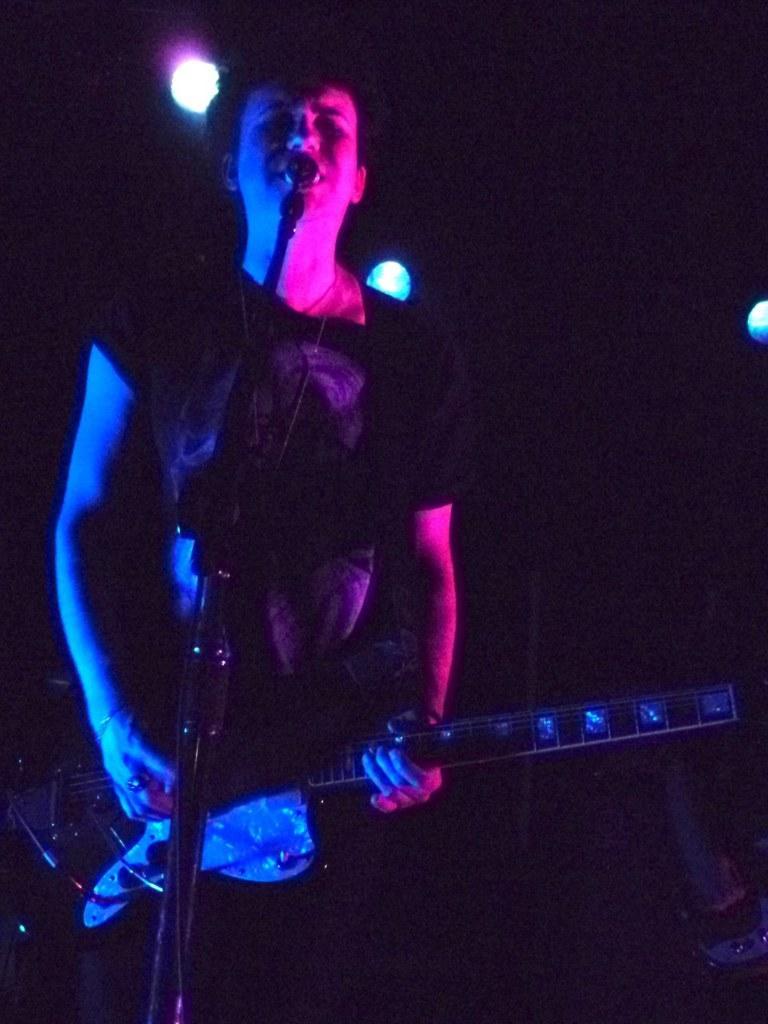Can you describe this image briefly? In this image I can see a person wearing black dress is standing in front of a microphone and holding a guitar in his hands. In the background I can see few lights and the dark background. 